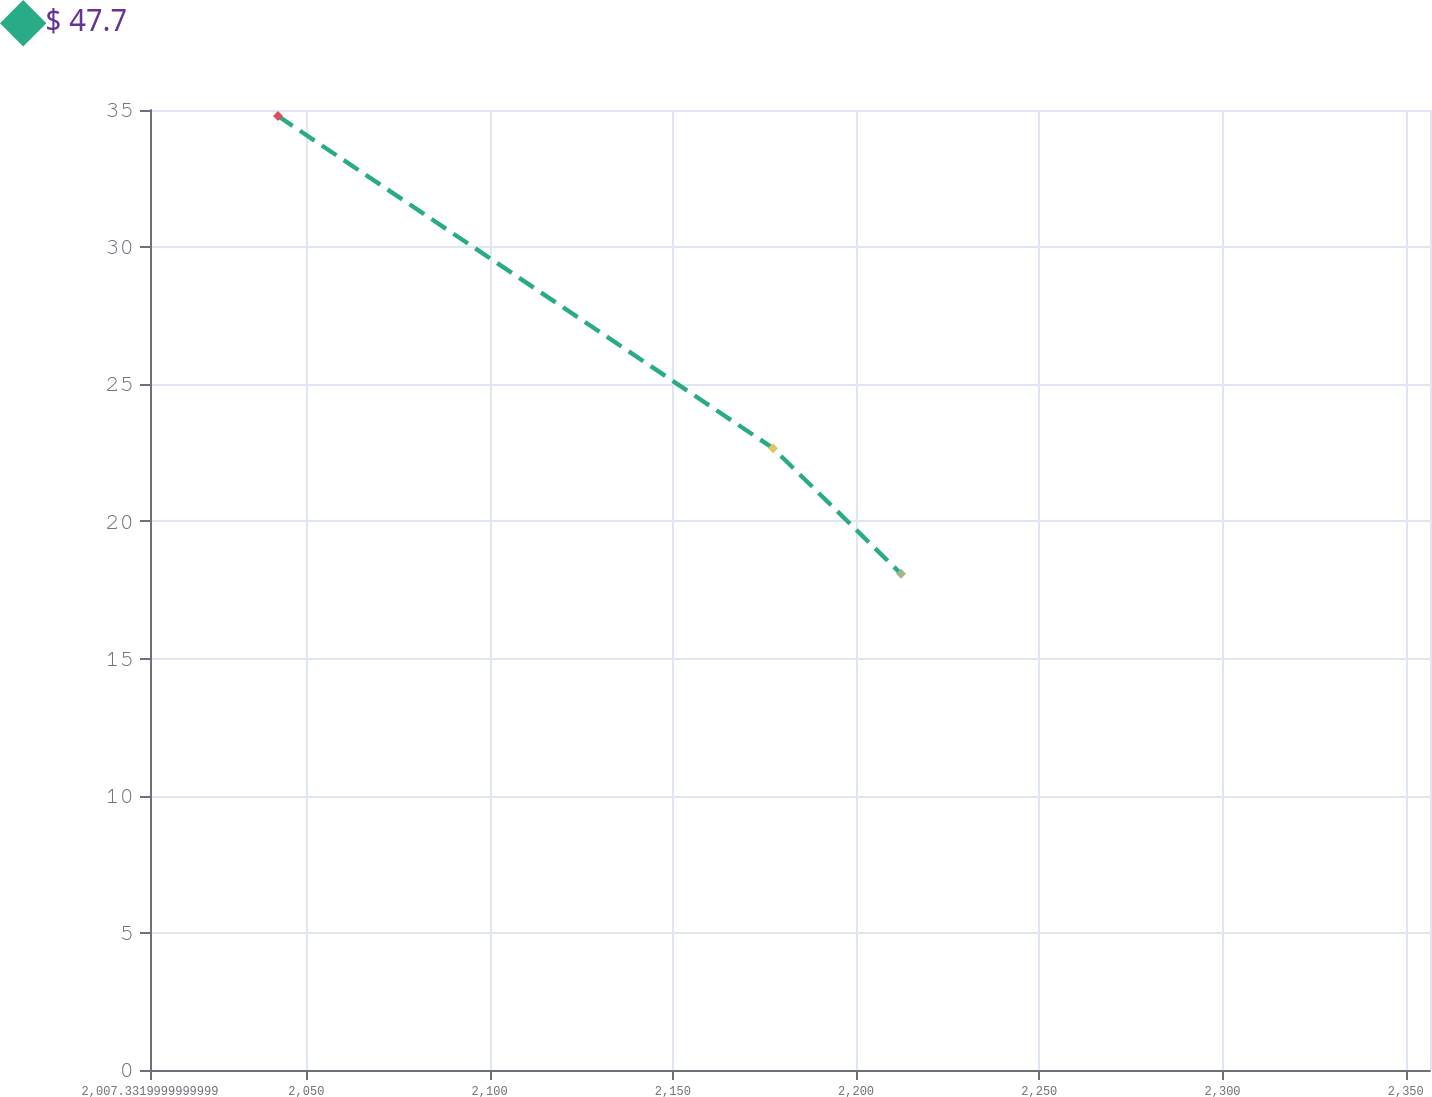Convert chart to OTSL. <chart><loc_0><loc_0><loc_500><loc_500><line_chart><ecel><fcel>$ 47.7<nl><fcel>2042.26<fcel>34.78<nl><fcel>2177.33<fcel>22.67<nl><fcel>2212.26<fcel>18.09<nl><fcel>2391.54<fcel>12.02<nl></chart> 